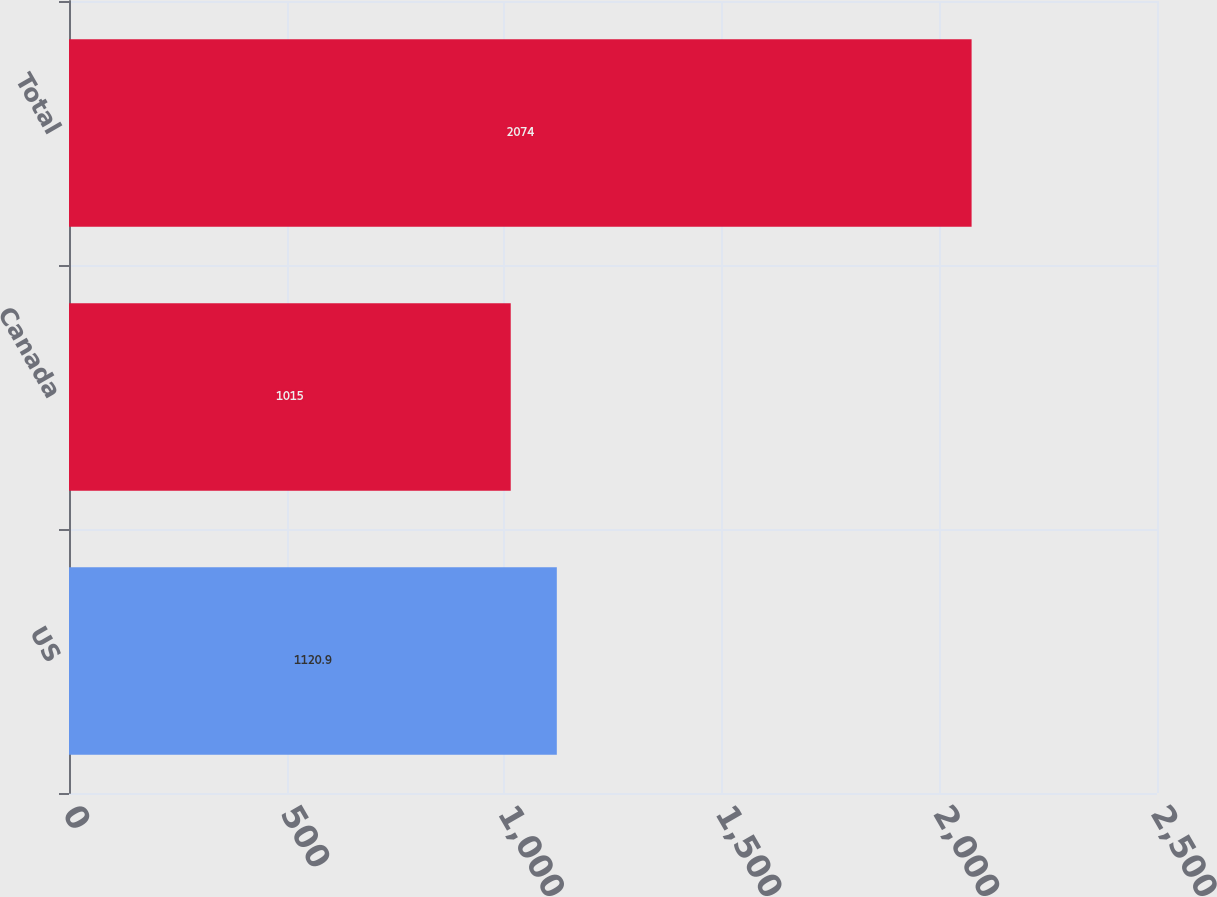<chart> <loc_0><loc_0><loc_500><loc_500><bar_chart><fcel>US<fcel>Canada<fcel>Total<nl><fcel>1120.9<fcel>1015<fcel>2074<nl></chart> 